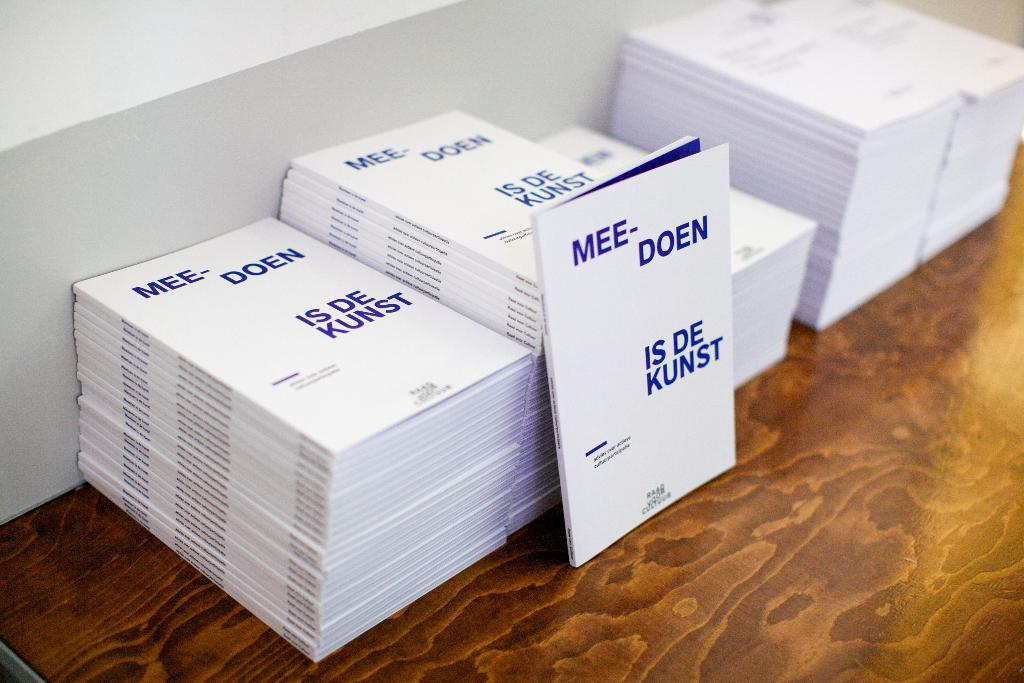<image>
Describe the image concisely. Many white booklets with Mee- Doen Is De Kunst on their cover sit in stacks. 